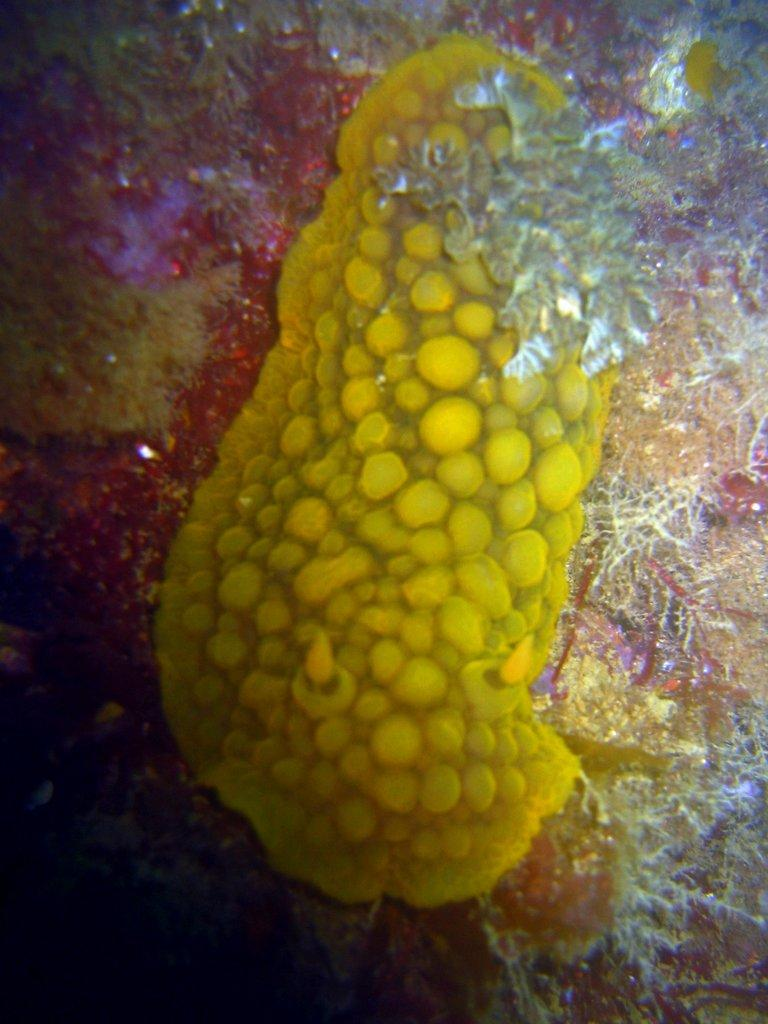What type of organisms can be seen in the water in the image? There are microorganisms in the water in the image. What type of yam is being used to make the payment for the flower in the image? There is no yam, payment, or flower present in the image; it only features microorganisms in the water. 